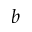<formula> <loc_0><loc_0><loc_500><loc_500>b</formula> 